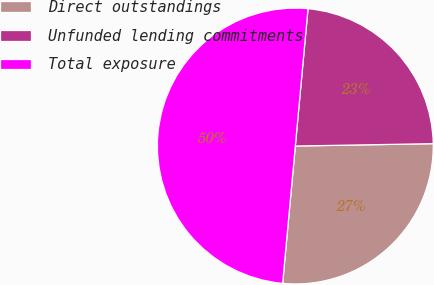<chart> <loc_0><loc_0><loc_500><loc_500><pie_chart><fcel>Direct outstandings<fcel>Unfunded lending commitments<fcel>Total exposure<nl><fcel>26.74%<fcel>23.26%<fcel>50.0%<nl></chart> 